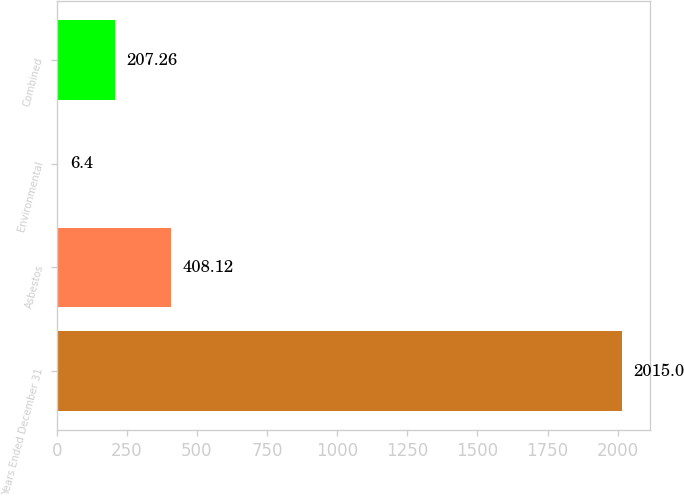Convert chart to OTSL. <chart><loc_0><loc_0><loc_500><loc_500><bar_chart><fcel>Years Ended December 31<fcel>Asbestos<fcel>Environmental<fcel>Combined<nl><fcel>2015<fcel>408.12<fcel>6.4<fcel>207.26<nl></chart> 